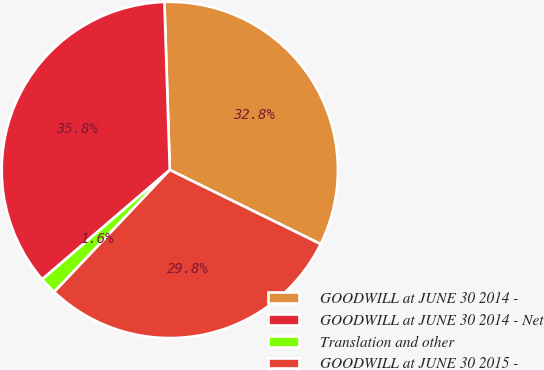Convert chart to OTSL. <chart><loc_0><loc_0><loc_500><loc_500><pie_chart><fcel>GOODWILL at JUNE 30 2014 -<fcel>GOODWILL at JUNE 30 2014 - Net<fcel>Translation and other<fcel>GOODWILL at JUNE 30 2015 -<nl><fcel>32.78%<fcel>35.77%<fcel>1.65%<fcel>29.8%<nl></chart> 